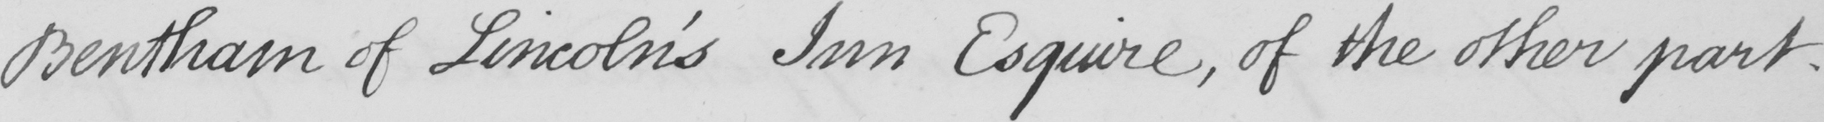Transcribe the text shown in this historical manuscript line. Bentham of Lincoln ' s Inn Esquire , of the other part . 